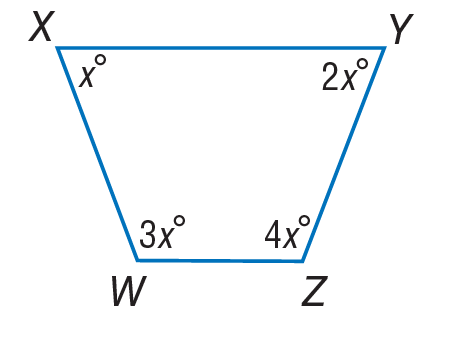Answer the mathemtical geometry problem and directly provide the correct option letter.
Question: Find m \angle Y.
Choices: A: 18 B: 36 C: 72 D: 144 C 